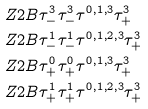<formula> <loc_0><loc_0><loc_500><loc_500>& Z 2 B \tau ^ { 3 } _ { - } \tau ^ { 3 } _ { - } \tau ^ { 0 , 1 , 3 } \tau ^ { 3 } _ { + } \\ & Z 2 B \tau ^ { 1 } _ { - } \tau ^ { 1 } _ { - } \tau ^ { 0 , 1 , 2 , 3 } \tau ^ { 3 } _ { + } \\ & Z 2 B \tau ^ { 0 } _ { + } \tau ^ { 0 } _ { + } \tau ^ { 0 , 1 , 3 } \tau ^ { 3 } _ { + } \\ & Z 2 B \tau ^ { 1 } _ { + } \tau ^ { 1 } _ { + } \tau ^ { 0 , 1 , 2 , 3 } \tau ^ { 3 } _ { + }</formula> 